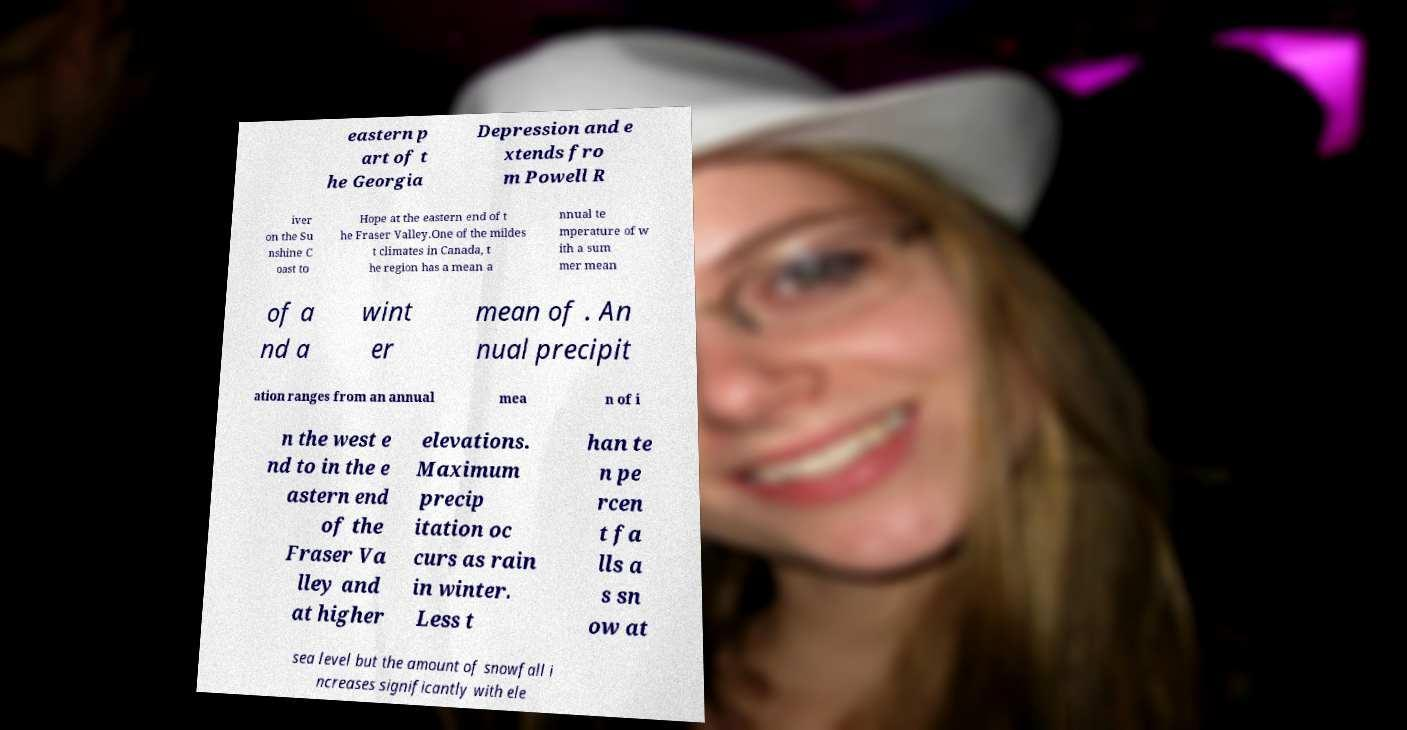For documentation purposes, I need the text within this image transcribed. Could you provide that? eastern p art of t he Georgia Depression and e xtends fro m Powell R iver on the Su nshine C oast to Hope at the eastern end of t he Fraser Valley.One of the mildes t climates in Canada, t he region has a mean a nnual te mperature of w ith a sum mer mean of a nd a wint er mean of . An nual precipit ation ranges from an annual mea n of i n the west e nd to in the e astern end of the Fraser Va lley and at higher elevations. Maximum precip itation oc curs as rain in winter. Less t han te n pe rcen t fa lls a s sn ow at sea level but the amount of snowfall i ncreases significantly with ele 